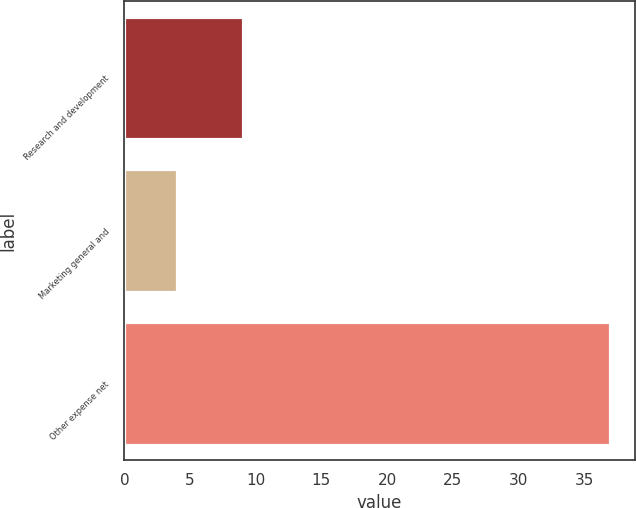<chart> <loc_0><loc_0><loc_500><loc_500><bar_chart><fcel>Research and development<fcel>Marketing general and<fcel>Other expense net<nl><fcel>9<fcel>4<fcel>37<nl></chart> 